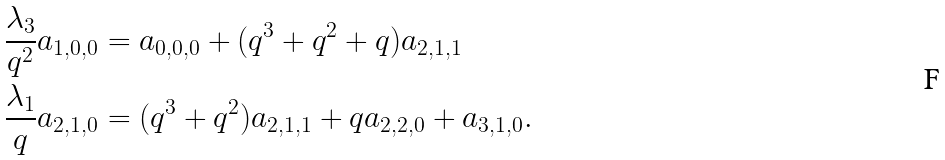Convert formula to latex. <formula><loc_0><loc_0><loc_500><loc_500>& \frac { \lambda _ { 3 } } { q ^ { 2 } } a _ { 1 , 0 , 0 } = a _ { 0 , 0 , 0 } + ( q ^ { 3 } + q ^ { 2 } + q ) a _ { 2 , 1 , 1 } \\ & \frac { \lambda _ { 1 } } { q } a _ { 2 , 1 , 0 } = ( q ^ { 3 } + q ^ { 2 } ) a _ { 2 , 1 , 1 } + q a _ { 2 , 2 , 0 } + a _ { 3 , 1 , 0 } .</formula> 